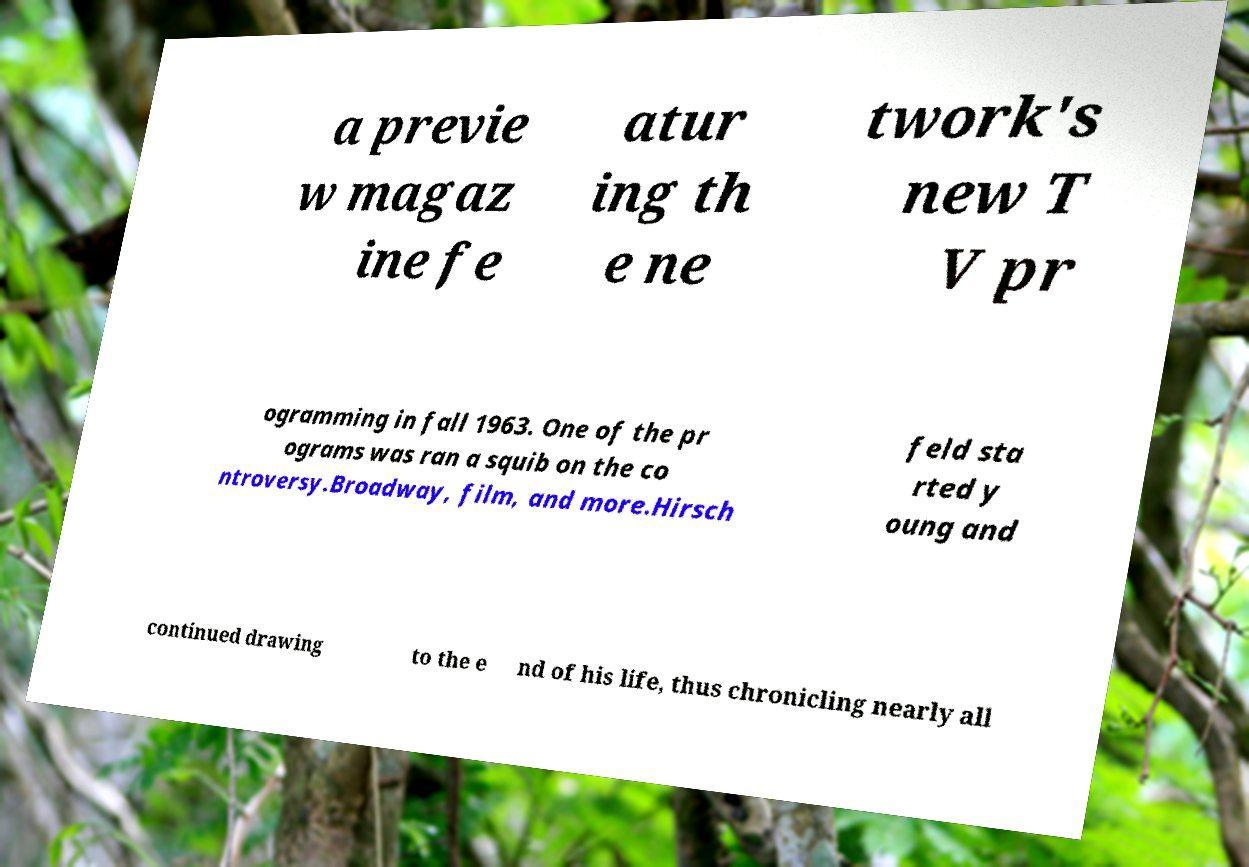Please identify and transcribe the text found in this image. a previe w magaz ine fe atur ing th e ne twork's new T V pr ogramming in fall 1963. One of the pr ograms was ran a squib on the co ntroversy.Broadway, film, and more.Hirsch feld sta rted y oung and continued drawing to the e nd of his life, thus chronicling nearly all 